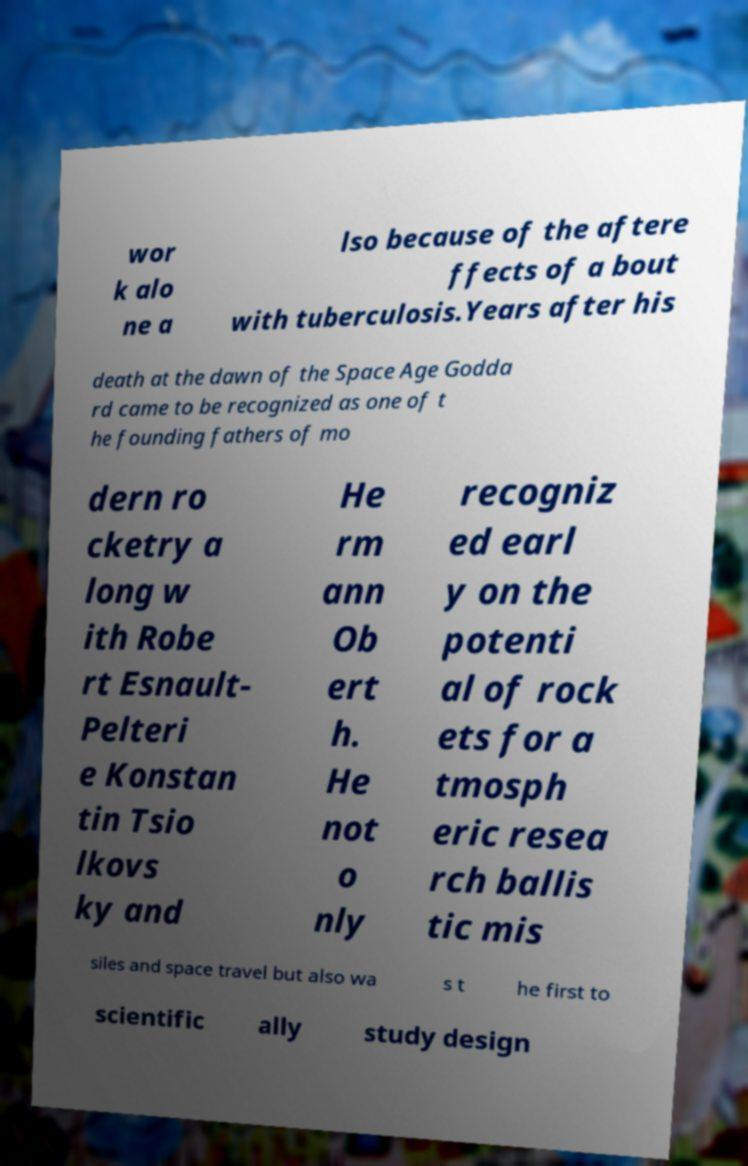What messages or text are displayed in this image? I need them in a readable, typed format. wor k alo ne a lso because of the aftere ffects of a bout with tuberculosis.Years after his death at the dawn of the Space Age Godda rd came to be recognized as one of t he founding fathers of mo dern ro cketry a long w ith Robe rt Esnault- Pelteri e Konstan tin Tsio lkovs ky and He rm ann Ob ert h. He not o nly recogniz ed earl y on the potenti al of rock ets for a tmosph eric resea rch ballis tic mis siles and space travel but also wa s t he first to scientific ally study design 